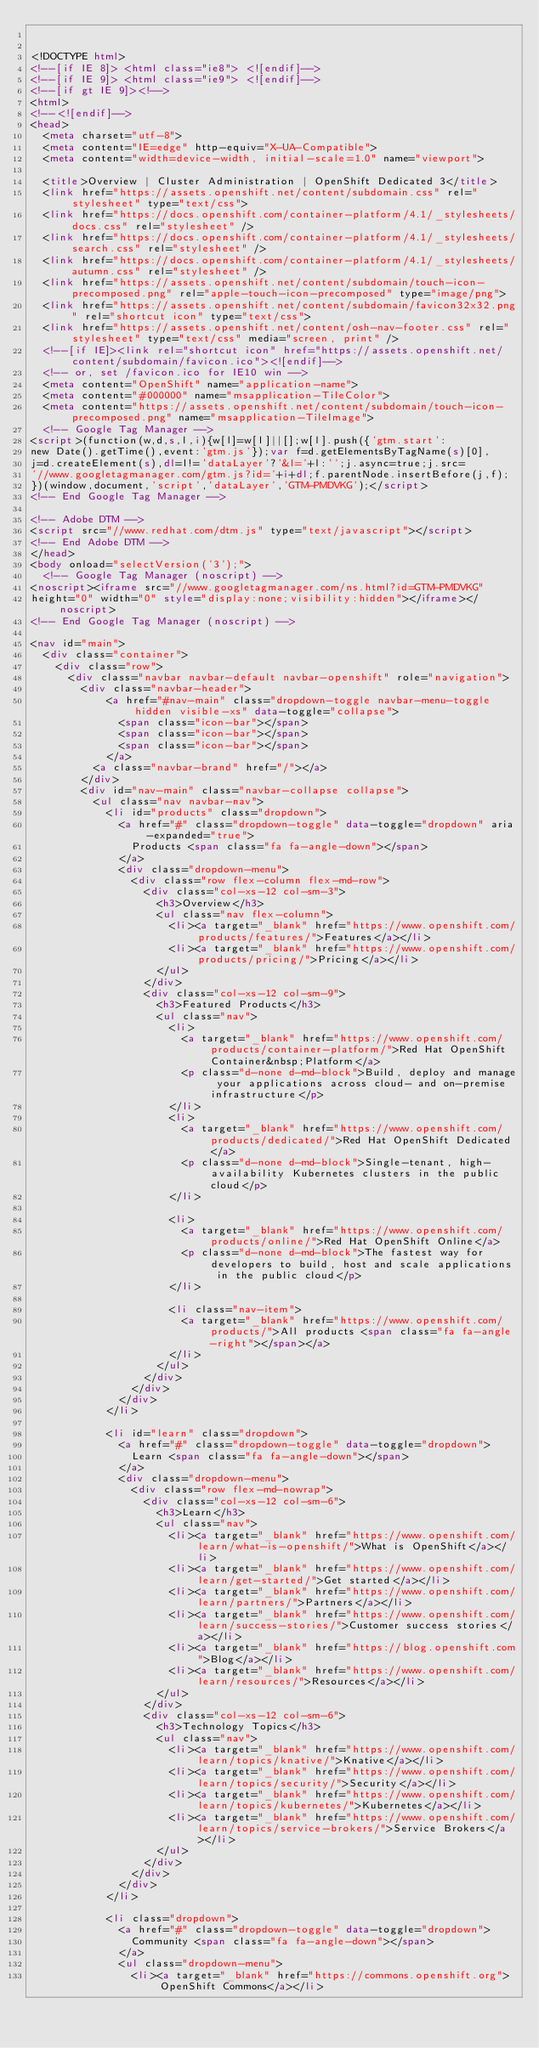<code> <loc_0><loc_0><loc_500><loc_500><_HTML_>

<!DOCTYPE html>
<!--[if IE 8]> <html class="ie8"> <![endif]-->
<!--[if IE 9]> <html class="ie9"> <![endif]-->
<!--[if gt IE 9]><!-->
<html>
<!--<![endif]-->
<head>
  <meta charset="utf-8">
  <meta content="IE=edge" http-equiv="X-UA-Compatible">
  <meta content="width=device-width, initial-scale=1.0" name="viewport">
  
  <title>Overview | Cluster Administration | OpenShift Dedicated 3</title>
  <link href="https://assets.openshift.net/content/subdomain.css" rel="stylesheet" type="text/css">
  <link href="https://docs.openshift.com/container-platform/4.1/_stylesheets/docs.css" rel="stylesheet" />
  <link href="https://docs.openshift.com/container-platform/4.1/_stylesheets/search.css" rel="stylesheet" />
  <link href="https://docs.openshift.com/container-platform/4.1/_stylesheets/autumn.css" rel="stylesheet" />
  <link href="https://assets.openshift.net/content/subdomain/touch-icon-precomposed.png" rel="apple-touch-icon-precomposed" type="image/png">
  <link href="https://assets.openshift.net/content/subdomain/favicon32x32.png" rel="shortcut icon" type="text/css">
  <link href="https://assets.openshift.net/content/osh-nav-footer.css" rel="stylesheet" type="text/css" media="screen, print" />
  <!--[if IE]><link rel="shortcut icon" href="https://assets.openshift.net/content/subdomain/favicon.ico"><![endif]-->
  <!-- or, set /favicon.ico for IE10 win -->
  <meta content="OpenShift" name="application-name">
  <meta content="#000000" name="msapplication-TileColor">
  <meta content="https://assets.openshift.net/content/subdomain/touch-icon-precomposed.png" name="msapplication-TileImage">
  <!-- Google Tag Manager -->
<script>(function(w,d,s,l,i){w[l]=w[l]||[];w[l].push({'gtm.start':
new Date().getTime(),event:'gtm.js'});var f=d.getElementsByTagName(s)[0],
j=d.createElement(s),dl=l!='dataLayer'?'&l='+l:'';j.async=true;j.src=
'//www.googletagmanager.com/gtm.js?id='+i+dl;f.parentNode.insertBefore(j,f);
})(window,document,'script','dataLayer','GTM-PMDVKG');</script>
<!-- End Google Tag Manager -->

<!-- Adobe DTM -->
<script src="//www.redhat.com/dtm.js" type="text/javascript"></script>
<!-- End Adobe DTM -->
</head>
<body onload="selectVersion('3');">
  <!-- Google Tag Manager (noscript) -->
<noscript><iframe src="//www.googletagmanager.com/ns.html?id=GTM-PMDVKG"
height="0" width="0" style="display:none;visibility:hidden"></iframe></noscript>
<!-- End Google Tag Manager (noscript) -->

<nav id="main">
  <div class="container">
    <div class="row">
      <div class="navbar navbar-default navbar-openshift" role="navigation">
        <div class="navbar-header">
            <a href="#nav-main" class="dropdown-toggle navbar-menu-toggle hidden visible-xs" data-toggle="collapse">
              <span class="icon-bar"></span>
              <span class="icon-bar"></span>
              <span class="icon-bar"></span>
            </a>
          <a class="navbar-brand" href="/"></a>
        </div>
        <div id="nav-main" class="navbar-collapse collapse">
          <ul class="nav navbar-nav">
            <li id="products" class="dropdown">
              <a href="#" class="dropdown-toggle" data-toggle="dropdown" aria-expanded="true">
                Products <span class="fa fa-angle-down"></span>
              </a>
              <div class="dropdown-menu">
                <div class="row flex-column flex-md-row">
                  <div class="col-xs-12 col-sm-3">
                    <h3>Overview</h3>
                    <ul class="nav flex-column">
                      <li><a target="_blank" href="https://www.openshift.com/products/features/">Features</a></li>
                      <li><a target="_blank" href="https://www.openshift.com/products/pricing/">Pricing</a></li>
                    </ul>
                  </div>
                  <div class="col-xs-12 col-sm-9">
                    <h3>Featured Products</h3>
                    <ul class="nav">
                      <li>
                        <a target="_blank" href="https://www.openshift.com/products/container-platform/">Red Hat OpenShift Container&nbsp;Platform</a>
                        <p class="d-none d-md-block">Build, deploy and manage your applications across cloud- and on-premise infrastructure</p>
                      </li>
                      <li>
                        <a target="_blank" href="https://www.openshift.com/products/dedicated/">Red Hat OpenShift Dedicated</a>
                        <p class="d-none d-md-block">Single-tenant, high-availability Kubernetes clusters in the public cloud</p>
                      </li>

                      <li>
                        <a target="_blank" href="https://www.openshift.com/products/online/">Red Hat OpenShift Online</a>
                        <p class="d-none d-md-block">The fastest way for developers to build, host and scale applications in the public cloud</p>
                      </li>

                      <li class="nav-item">
                        <a target="_blank" href="https://www.openshift.com/products/">All products <span class="fa fa-angle-right"></span></a>
                      </li>
                    </ul>
                  </div>
                </div>
              </div>
            </li>

            <li id="learn" class="dropdown">
              <a href="#" class="dropdown-toggle" data-toggle="dropdown">
                Learn <span class="fa fa-angle-down"></span>
              </a>
              <div class="dropdown-menu">
                <div class="row flex-md-nowrap">
                  <div class="col-xs-12 col-sm-6">
                    <h3>Learn</h3>
                    <ul class="nav">
                      <li><a target="_blank" href="https://www.openshift.com/learn/what-is-openshift/">What is OpenShift</a></li>
                      <li><a target="_blank" href="https://www.openshift.com/learn/get-started/">Get started</a></li>
                      <li><a target="_blank" href="https://www.openshift.com/learn/partners/">Partners</a></li>
                      <li><a target="_blank" href="https://www.openshift.com/learn/success-stories/">Customer success stories</a></li>
                      <li><a target="_blank" href="https://blog.openshift.com">Blog</a></li>
                      <li><a target="_blank" href="https://www.openshift.com/learn/resources/">Resources</a></li>
                    </ul>
                  </div>
                  <div class="col-xs-12 col-sm-6">
                    <h3>Technology Topics</h3>
                    <ul class="nav">
                      <li><a target="_blank" href="https://www.openshift.com/learn/topics/knative/">Knative</a></li>
                      <li><a target="_blank" href="https://www.openshift.com/learn/topics/security/">Security</a></li>
                      <li><a target="_blank" href="https://www.openshift.com/learn/topics/kubernetes/">Kubernetes</a></li>
                      <li><a target="_blank" href="https://www.openshift.com/learn/topics/service-brokers/">Service Brokers</a></li>
                    </ul>
                  </div>
                </div>
              </div>
            </li>

            <li class="dropdown">
              <a href="#" class="dropdown-toggle" data-toggle="dropdown">
                Community <span class="fa fa-angle-down"></span>
              </a>
              <ul class="dropdown-menu">
                <li><a target="_blank" href="https://commons.openshift.org">OpenShift Commons</a></li></code> 